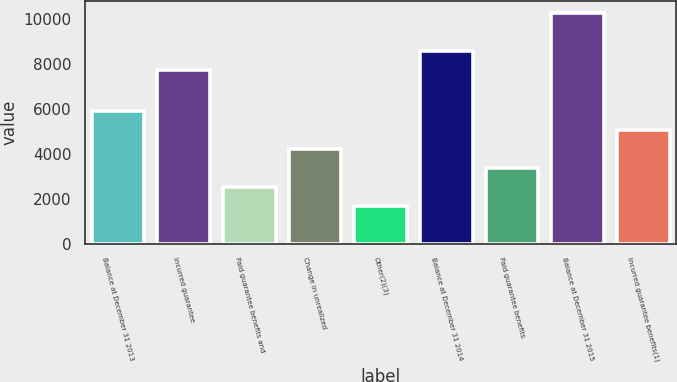Convert chart. <chart><loc_0><loc_0><loc_500><loc_500><bar_chart><fcel>Balance at December 31 2013<fcel>Incurred guarantee<fcel>Paid guarantee benefits and<fcel>Change in unrealized<fcel>Other(2)(3)<fcel>Balance at December 31 2014<fcel>Paid guarantee benefits<fcel>Balance at December 31 2015<fcel>Incurred guarantee benefits(1)<nl><fcel>5903.4<fcel>7741<fcel>2530.6<fcel>4217<fcel>1687.4<fcel>8584.2<fcel>3373.8<fcel>10270.6<fcel>5060.2<nl></chart> 